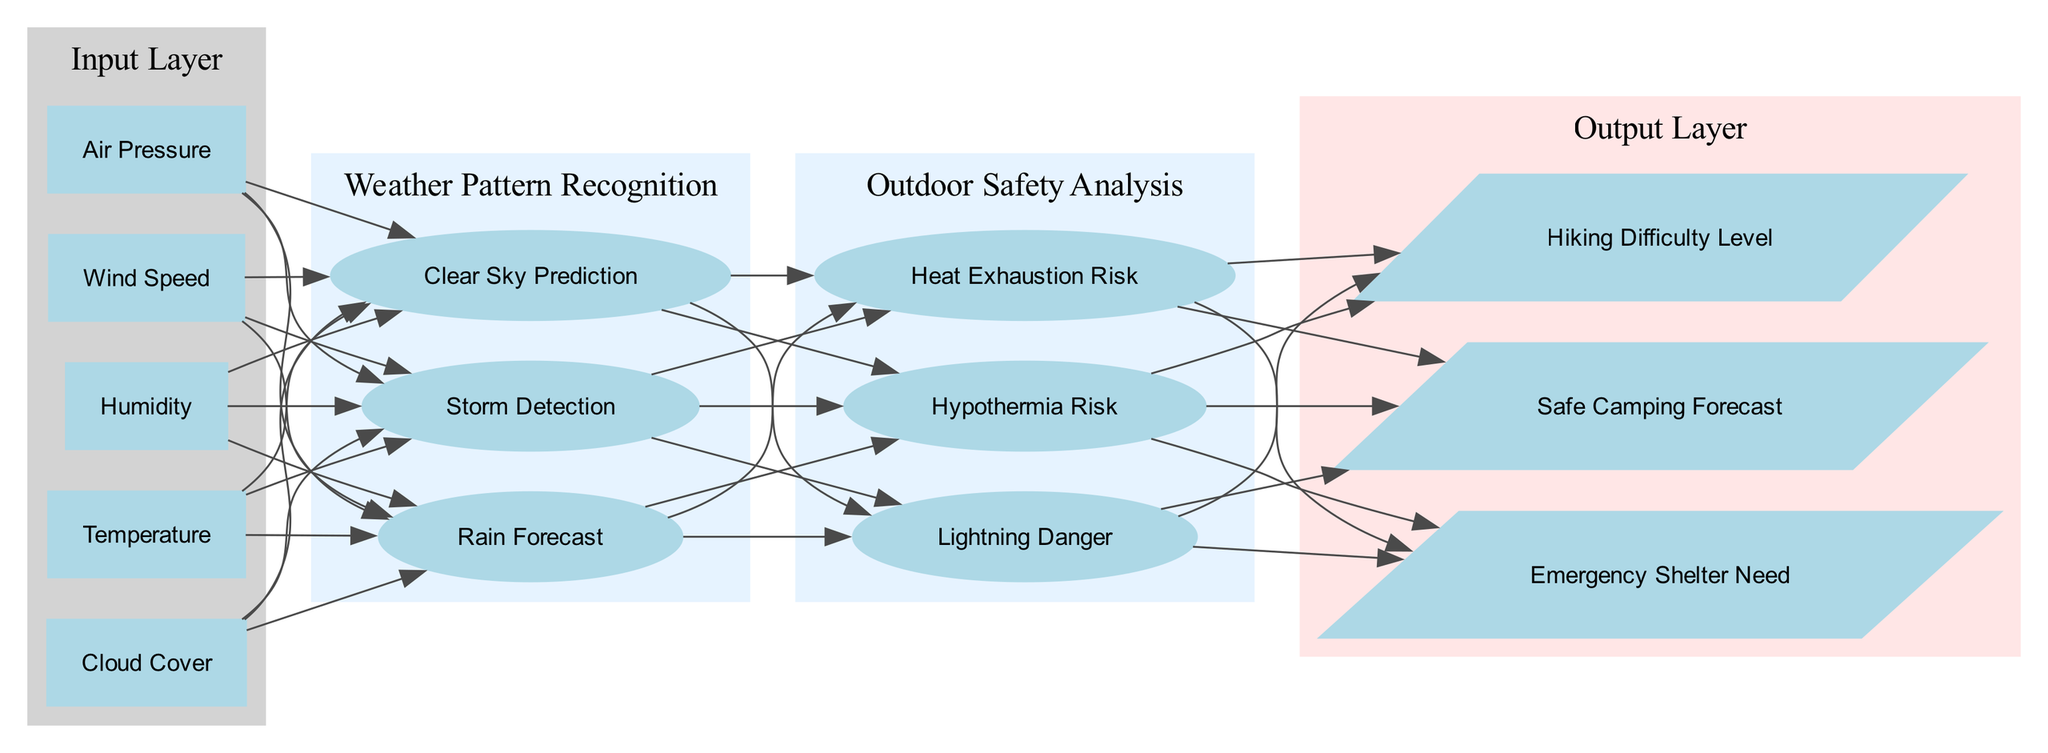What are the inputs to the neural network? The input layer of the diagram includes five parameters: Temperature, Humidity, Wind Speed, Air Pressure, and Cloud Cover.
Answer: Temperature, Humidity, Wind Speed, Air Pressure, Cloud Cover How many nodes are present in the "Outdoor Safety Analysis" layer? The hidden layer named "Outdoor Safety Analysis" has three nodes: Hypothermia Risk, Heat Exhaustion Risk, and Lightning Danger.
Answer: 3 What is the first hidden layer named? The first hidden layer in the diagram is titled "Weather Pattern Recognition." This layer is responsible for recognizing meteorological patterns.
Answer: Weather Pattern Recognition How do the input nodes connect to the hidden layer nodes? All nodes in the input layer connect to all nodes in the first hidden layer, "Weather Pattern Recognition," signifying that every input is considered for pattern recognition.
Answer: All input nodes to Weather Pattern Recognition nodes Which output node is directly influenced by "Heat Exhaustion Risk"? The "Heat Exhaustion Risk" node in the second hidden layer connects directly to the output node titled "Emergency Shelter Need." It indicates that this risk influences the need for emergency shelter.
Answer: Emergency Shelter Need What is the final output of the neural network? The final output layer consists of three possible outputs: Safe Camping Forecast, Hiking Difficulty Level, and Emergency Shelter Need. This indicates the different predictions the network can make based on the input data.
Answer: Safe Camping Forecast, Hiking Difficulty Level, Emergency Shelter Need Which hidden layer processes weather patterns before assessing safety? The hidden layer named "Weather Pattern Recognition" is the first hidden layer, processing weather information before passing insights to the "Outdoor Safety Analysis" layer for safety assessments.
Answer: Weather Pattern Recognition What is the connection flow from the output layer? The connection flow means that the output from the hidden layer "Outdoor Safety Analysis" influences the three output nodes, reflecting a sequential process where safety analyses lead to the final outputs.
Answer: From Outdoor Safety Analysis to output layer 